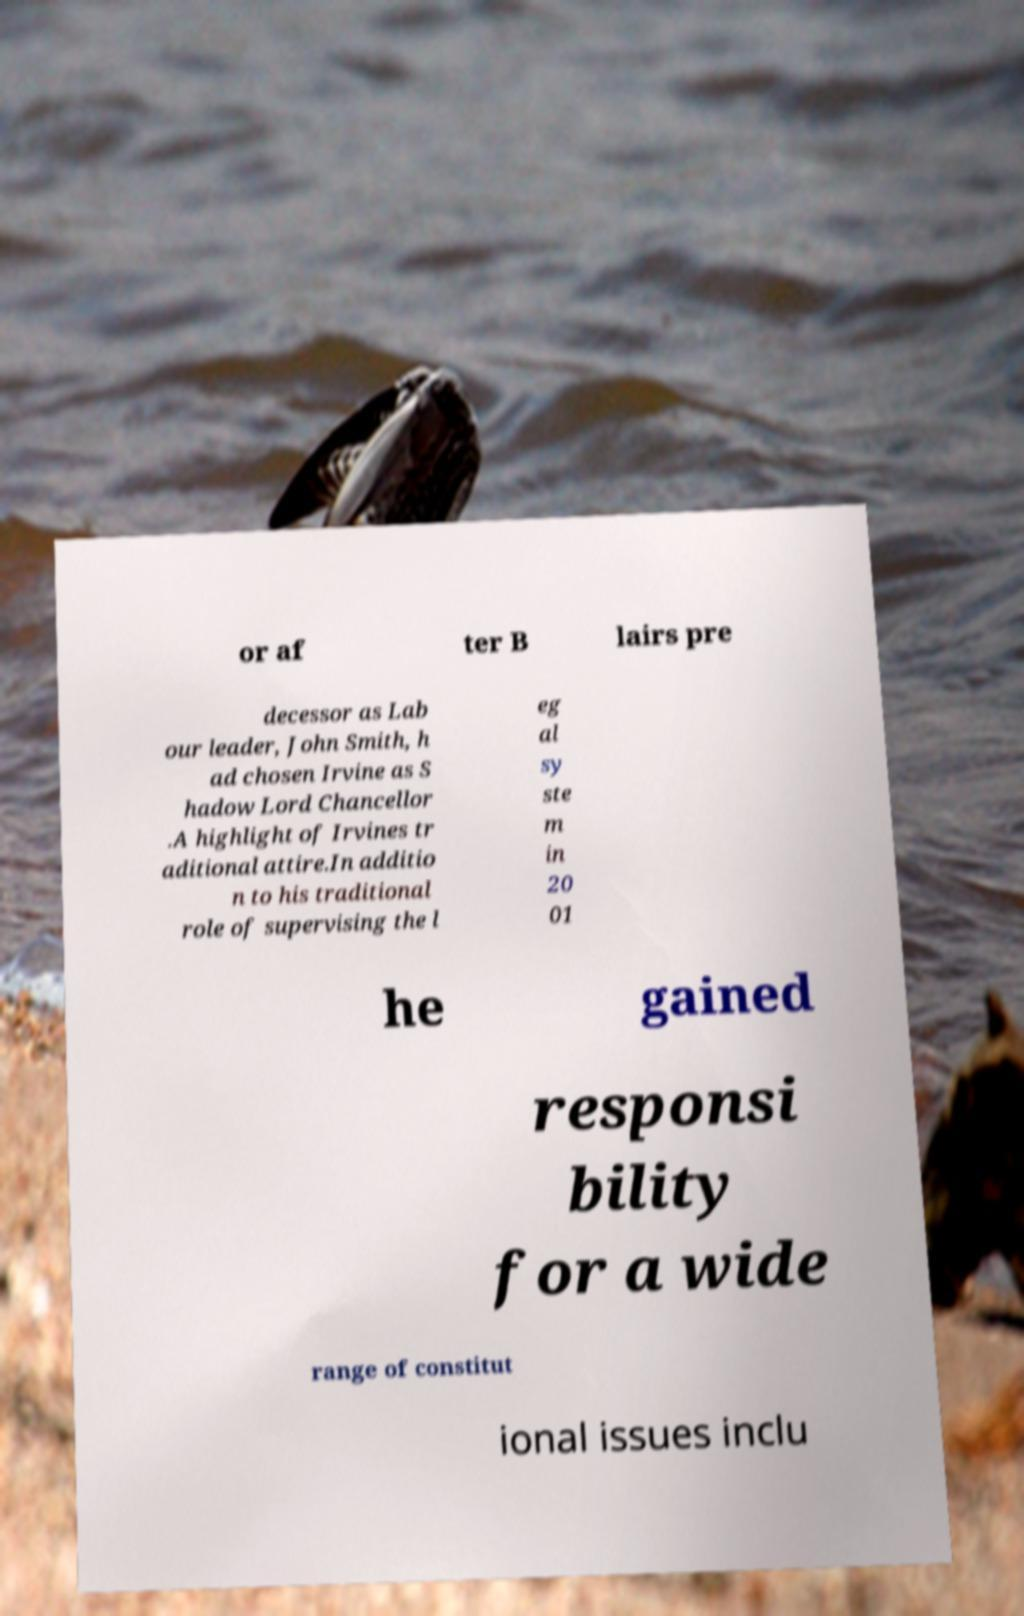I need the written content from this picture converted into text. Can you do that? or af ter B lairs pre decessor as Lab our leader, John Smith, h ad chosen Irvine as S hadow Lord Chancellor .A highlight of Irvines tr aditional attire.In additio n to his traditional role of supervising the l eg al sy ste m in 20 01 he gained responsi bility for a wide range of constitut ional issues inclu 